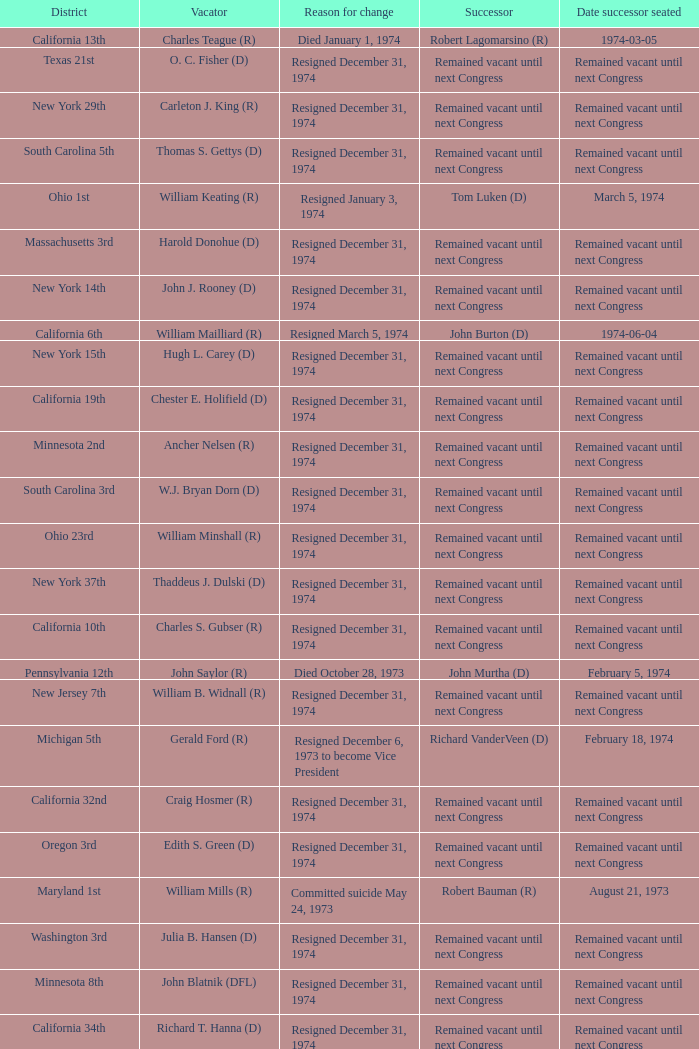When was the successor seated when the district was California 10th? Remained vacant until next Congress. Give me the full table as a dictionary. {'header': ['District', 'Vacator', 'Reason for change', 'Successor', 'Date successor seated'], 'rows': [['California 13th', 'Charles Teague (R)', 'Died January 1, 1974', 'Robert Lagomarsino (R)', '1974-03-05'], ['Texas 21st', 'O. C. Fisher (D)', 'Resigned December 31, 1974', 'Remained vacant until next Congress', 'Remained vacant until next Congress'], ['New York 29th', 'Carleton J. King (R)', 'Resigned December 31, 1974', 'Remained vacant until next Congress', 'Remained vacant until next Congress'], ['South Carolina 5th', 'Thomas S. Gettys (D)', 'Resigned December 31, 1974', 'Remained vacant until next Congress', 'Remained vacant until next Congress'], ['Ohio 1st', 'William Keating (R)', 'Resigned January 3, 1974', 'Tom Luken (D)', 'March 5, 1974'], ['Massachusetts 3rd', 'Harold Donohue (D)', 'Resigned December 31, 1974', 'Remained vacant until next Congress', 'Remained vacant until next Congress'], ['New York 14th', 'John J. Rooney (D)', 'Resigned December 31, 1974', 'Remained vacant until next Congress', 'Remained vacant until next Congress'], ['California 6th', 'William Mailliard (R)', 'Resigned March 5, 1974', 'John Burton (D)', '1974-06-04'], ['New York 15th', 'Hugh L. Carey (D)', 'Resigned December 31, 1974', 'Remained vacant until next Congress', 'Remained vacant until next Congress'], ['California 19th', 'Chester E. Holifield (D)', 'Resigned December 31, 1974', 'Remained vacant until next Congress', 'Remained vacant until next Congress'], ['Minnesota 2nd', 'Ancher Nelsen (R)', 'Resigned December 31, 1974', 'Remained vacant until next Congress', 'Remained vacant until next Congress'], ['South Carolina 3rd', 'W.J. Bryan Dorn (D)', 'Resigned December 31, 1974', 'Remained vacant until next Congress', 'Remained vacant until next Congress'], ['Ohio 23rd', 'William Minshall (R)', 'Resigned December 31, 1974', 'Remained vacant until next Congress', 'Remained vacant until next Congress'], ['New York 37th', 'Thaddeus J. Dulski (D)', 'Resigned December 31, 1974', 'Remained vacant until next Congress', 'Remained vacant until next Congress'], ['California 10th', 'Charles S. Gubser (R)', 'Resigned December 31, 1974', 'Remained vacant until next Congress', 'Remained vacant until next Congress'], ['Pennsylvania 12th', 'John Saylor (R)', 'Died October 28, 1973', 'John Murtha (D)', 'February 5, 1974'], ['New Jersey 7th', 'William B. Widnall (R)', 'Resigned December 31, 1974', 'Remained vacant until next Congress', 'Remained vacant until next Congress'], ['Michigan 5th', 'Gerald Ford (R)', 'Resigned December 6, 1973 to become Vice President', 'Richard VanderVeen (D)', 'February 18, 1974'], ['California 32nd', 'Craig Hosmer (R)', 'Resigned December 31, 1974', 'Remained vacant until next Congress', 'Remained vacant until next Congress'], ['Oregon 3rd', 'Edith S. Green (D)', 'Resigned December 31, 1974', 'Remained vacant until next Congress', 'Remained vacant until next Congress'], ['Maryland 1st', 'William Mills (R)', 'Committed suicide May 24, 1973', 'Robert Bauman (R)', 'August 21, 1973'], ['Washington 3rd', 'Julia B. Hansen (D)', 'Resigned December 31, 1974', 'Remained vacant until next Congress', 'Remained vacant until next Congress'], ['Minnesota 8th', 'John Blatnik (DFL)', 'Resigned December 31, 1974', 'Remained vacant until next Congress', 'Remained vacant until next Congress'], ['California 34th', 'Richard T. Hanna (D)', 'Resigned December 31, 1974', 'Remained vacant until next Congress', 'Remained vacant until next Congress'], ['Michigan 7th', 'Donald W. Riegle, Jr. (R)', 'Switched party affiliation', 'Donald W. Riegle, Jr. (D)', 'February 27, 1973'], ['Michigan 6th', 'Charles E. Chamberlain (R)', 'Resigned December 31, 1974', 'Remained vacant until next Congress', 'Remained vacant until next Congress'], ['Illinois 24th', 'Kenneth J. Gray (D)', 'Resigned December 31, 1974', 'Remained vacant until next Congress', 'Remained vacant until next Congress'], ['Wisconsin 3rd', 'Vernon W. Thomson (R)', 'Resigned December 31, 1974', 'Remained vacant until next Congress', 'Remained vacant until next Congress'], ['Kentucky 1st', 'Frank Stubblefield (D)', 'Resigned December 31, 1974', 'Remained vacant until next Congress', 'Remained vacant until next Congress'], ['Michigan 17th', 'Martha Griffiths (D)', 'Resigned December 31, 1974', 'Remained vacant until next Congress', 'Remained vacant until next Congress'], ['Nebraska 3rd', 'David T. Martin (R)', 'Resigned December 31, 1974', 'Remained vacant until next Congress', 'Remained vacant until next Congress'], ['Pennsylvania 25th', 'Frank M. Clark (D)', 'Resigned December 31, 1974', 'Remained vacant until next Congress', 'Remained vacant until next Congress']]} 